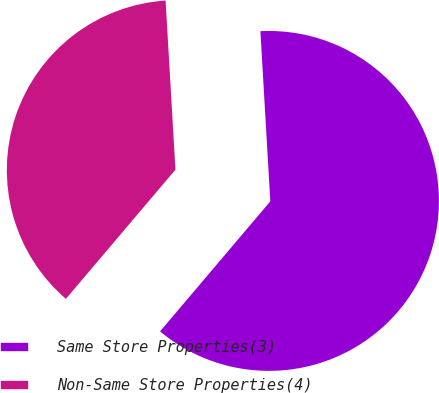Convert chart. <chart><loc_0><loc_0><loc_500><loc_500><pie_chart><fcel>Same Store Properties(3)<fcel>Non-Same Store Properties(4)<nl><fcel>62.12%<fcel>37.88%<nl></chart> 